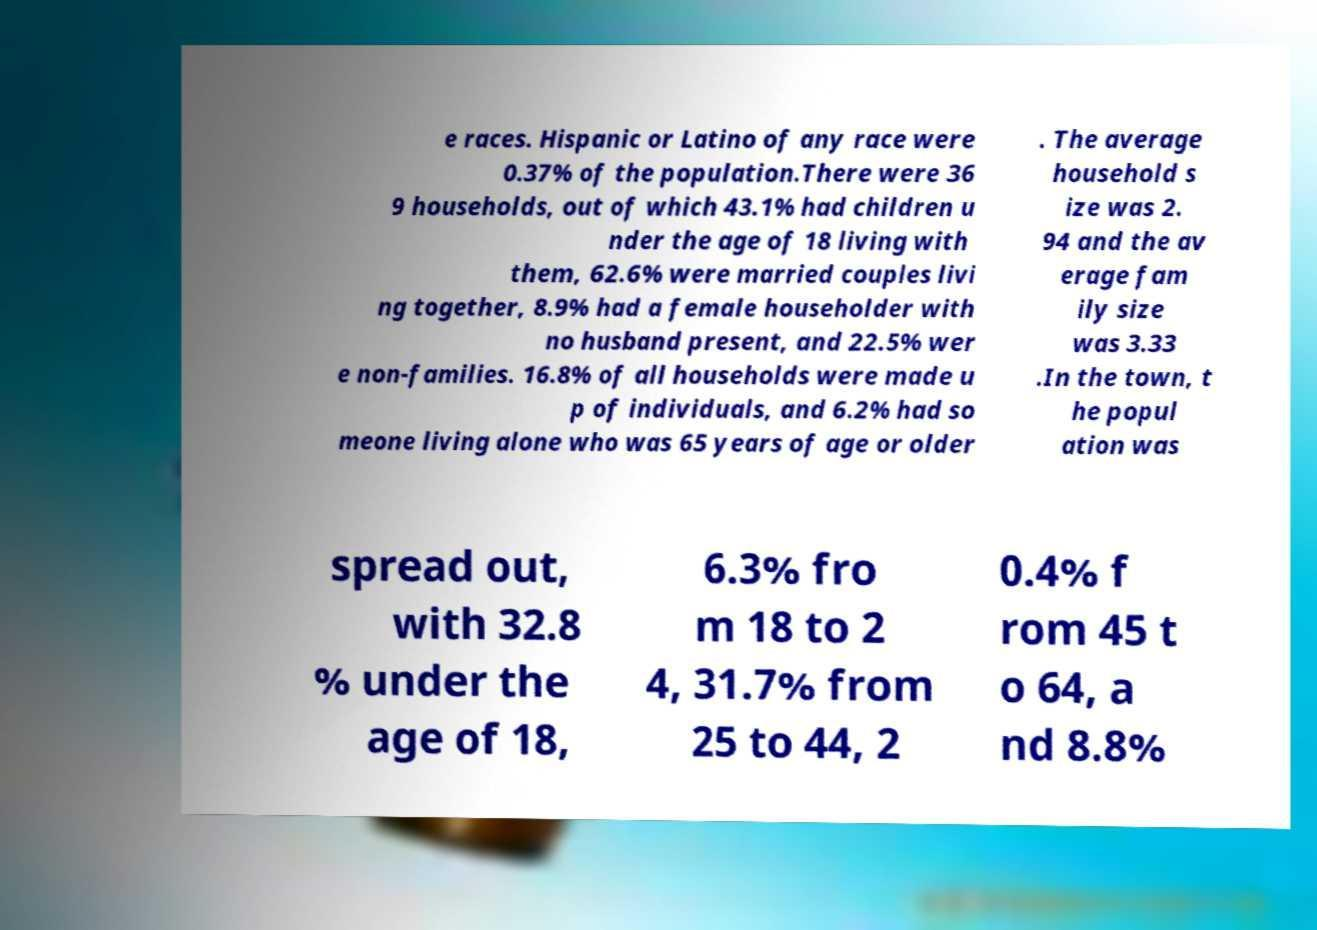What messages or text are displayed in this image? I need them in a readable, typed format. e races. Hispanic or Latino of any race were 0.37% of the population.There were 36 9 households, out of which 43.1% had children u nder the age of 18 living with them, 62.6% were married couples livi ng together, 8.9% had a female householder with no husband present, and 22.5% wer e non-families. 16.8% of all households were made u p of individuals, and 6.2% had so meone living alone who was 65 years of age or older . The average household s ize was 2. 94 and the av erage fam ily size was 3.33 .In the town, t he popul ation was spread out, with 32.8 % under the age of 18, 6.3% fro m 18 to 2 4, 31.7% from 25 to 44, 2 0.4% f rom 45 t o 64, a nd 8.8% 